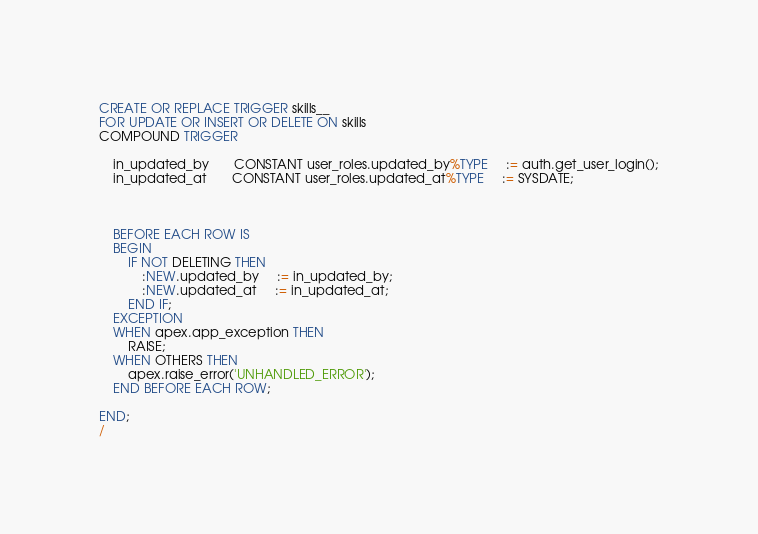Convert code to text. <code><loc_0><loc_0><loc_500><loc_500><_SQL_>CREATE OR REPLACE TRIGGER skills__
FOR UPDATE OR INSERT OR DELETE ON skills
COMPOUND TRIGGER

    in_updated_by       CONSTANT user_roles.updated_by%TYPE     := auth.get_user_login();
    in_updated_at       CONSTANT user_roles.updated_at%TYPE     := SYSDATE;



    BEFORE EACH ROW IS
    BEGIN
        IF NOT DELETING THEN
            :NEW.updated_by     := in_updated_by;
            :NEW.updated_at     := in_updated_at;
        END IF;
    EXCEPTION
    WHEN apex.app_exception THEN
        RAISE;
    WHEN OTHERS THEN
        apex.raise_error('UNHANDLED_ERROR');
    END BEFORE EACH ROW;

END;
/
</code> 